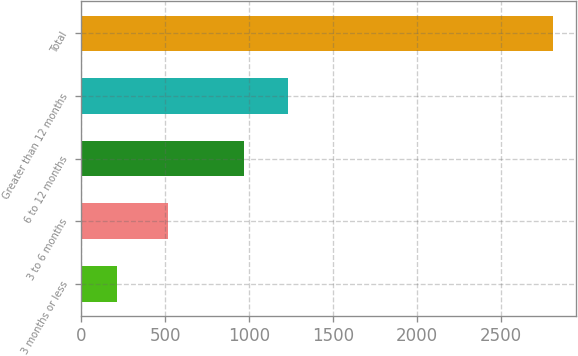<chart> <loc_0><loc_0><loc_500><loc_500><bar_chart><fcel>3 months or less<fcel>3 to 6 months<fcel>6 to 12 months<fcel>Greater than 12 months<fcel>Total<nl><fcel>212<fcel>515<fcel>971<fcel>1230.9<fcel>2811<nl></chart> 